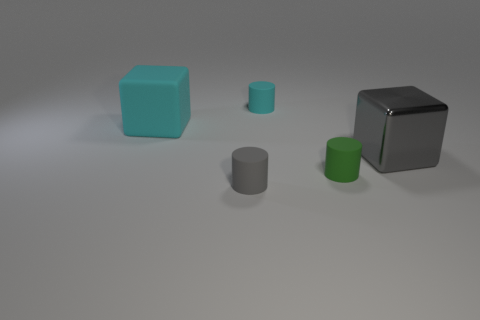Subtract all cylinders. How many objects are left? 2 Subtract 2 blocks. How many blocks are left? 0 Subtract all metallic cubes. Subtract all tiny gray matte things. How many objects are left? 3 Add 4 small gray cylinders. How many small gray cylinders are left? 5 Add 3 small yellow rubber blocks. How many small yellow rubber blocks exist? 3 Add 5 small blue rubber things. How many objects exist? 10 Subtract all cyan cubes. How many cubes are left? 1 Subtract 0 brown cylinders. How many objects are left? 5 Subtract all red cubes. Subtract all gray spheres. How many cubes are left? 2 Subtract all green cubes. How many cyan cylinders are left? 1 